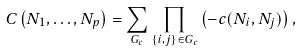Convert formula to latex. <formula><loc_0><loc_0><loc_500><loc_500>C \left ( N _ { 1 } , \dots , N _ { p } \right ) = \sum _ { G _ { c } } \prod _ { \{ i , j \} \in G _ { c } } \left ( - c ( N _ { i } , N _ { j } ) \right ) ,</formula> 